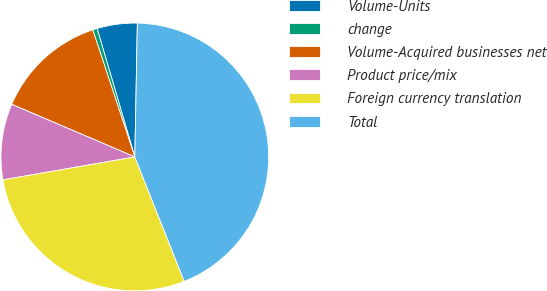Convert chart. <chart><loc_0><loc_0><loc_500><loc_500><pie_chart><fcel>Volume-Units<fcel>change<fcel>Volume-Acquired businesses net<fcel>Product price/mix<fcel>Foreign currency translation<fcel>Total<nl><fcel>4.85%<fcel>0.54%<fcel>13.48%<fcel>9.17%<fcel>28.28%<fcel>43.68%<nl></chart> 